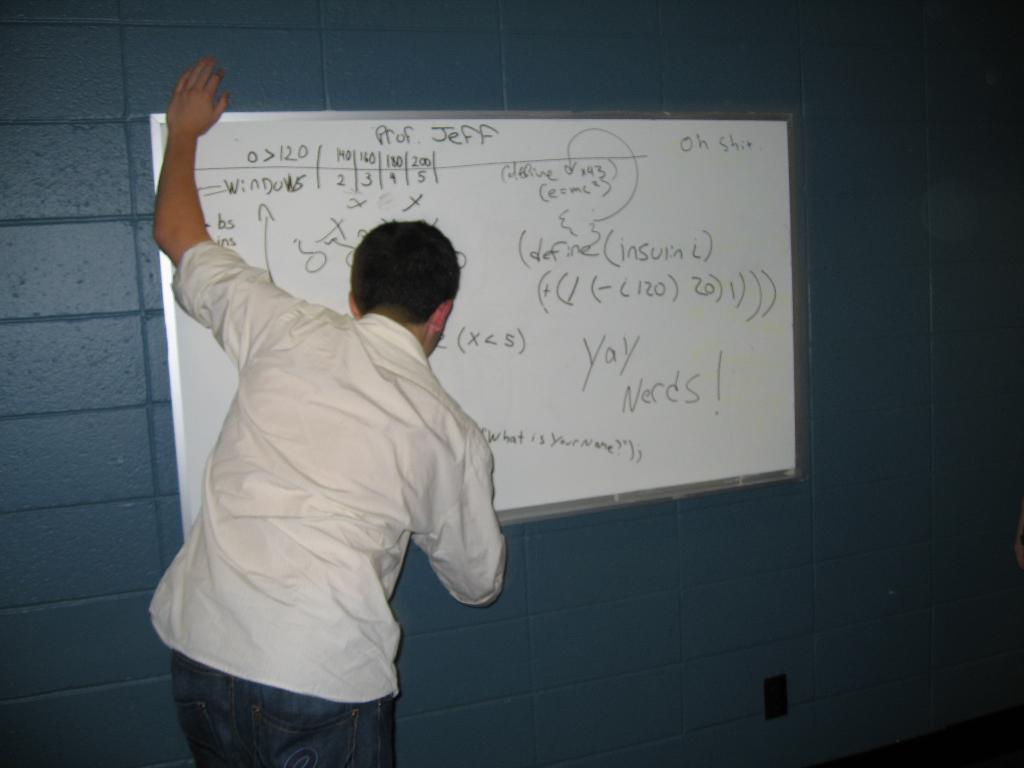Who is present in the image? There is a man in the image. What is the man wearing? The man is wearing a white shirt and blue jeans. What can be seen in the background of the image? There is a whiteboard in the image, and something is written on it. What color is the wall in the image? The wall in the image is blue. How many men are using the brake in the image? There is no brake present in the image, and therefore no men are using it. What type of shoes is the man wearing in the image? The provided facts do not mention the man's shoes, so we cannot determine the type of shoes he is wearing. 